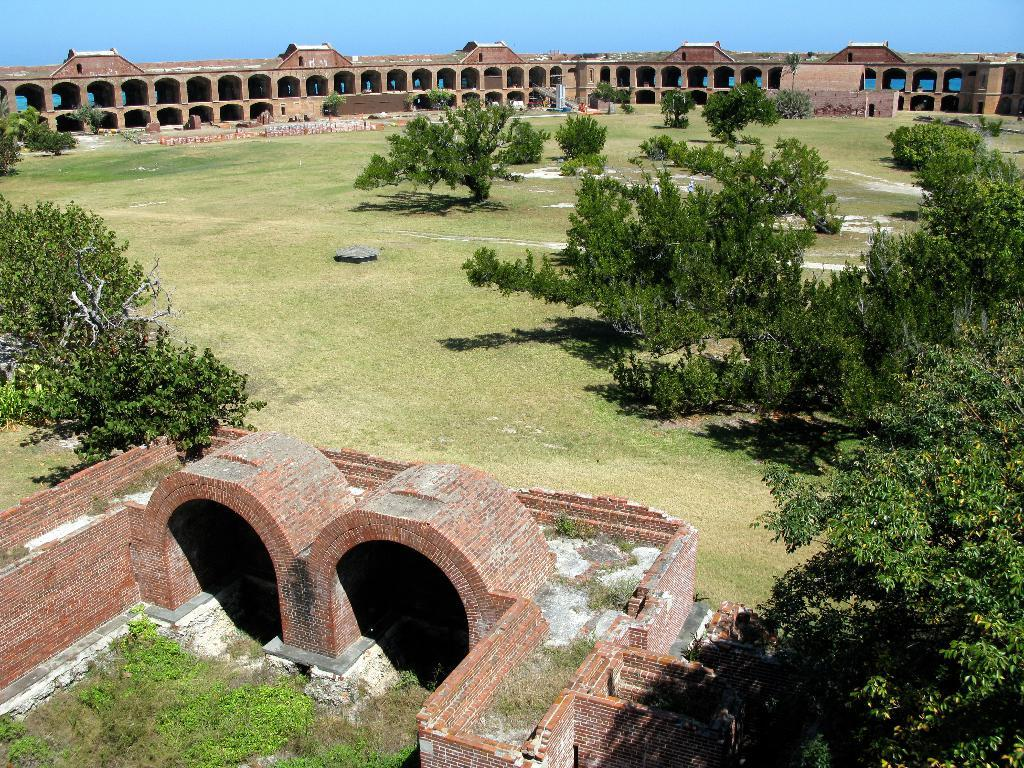What is located at the front of the image? There is a wall in the front of the image. What can be seen near the wall? There are plants near the wall. What type of vegetation is present in the center of the image? There is grass on the ground and trees in the center of the image. What is visible in the background of the image? There is a building in the background of the image. What type of underwear is hanging on the wall in the image? There is no underwear present in the image; it features a wall, plants, grass, trees, and a building. How does the building in the background turn around in the image? The building in the background does not turn around in the image; it is stationary. 